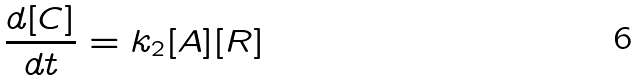Convert formula to latex. <formula><loc_0><loc_0><loc_500><loc_500>\frac { d [ C ] } { d t } = k _ { 2 } [ A ] [ R ]</formula> 